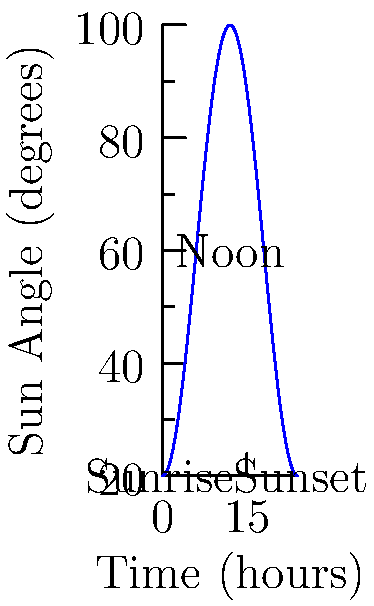The graph shows the angle of sunlight throughout a day in your garden. At what time does the sun reach its highest point, and what is the corresponding angle? To answer this question, we need to analyze the graph:

1. The x-axis represents time in hours (0-24), and the y-axis represents the sun angle in degrees.
2. The curve shows how the sun angle changes throughout the day.
3. The highest point on the curve represents the time when the sun is at its highest position in the sky.
4. Looking at the graph, we can see that the peak occurs at 12 hours (noon).
5. To find the corresponding angle, we need to read the y-value at x = 12.
6. The y-value at x = 12 is 60 degrees.

Therefore, the sun reaches its highest point at noon (12:00), and the corresponding angle is 60 degrees.
Answer: Noon (12:00), 60 degrees 